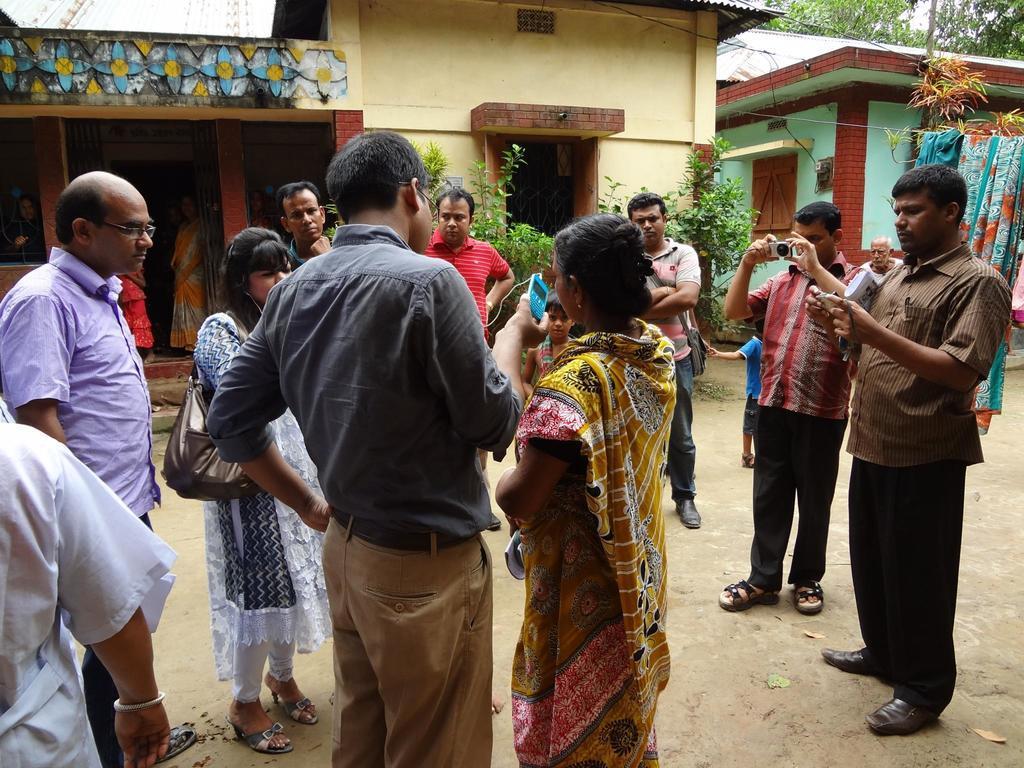In one or two sentences, can you explain what this image depicts? In this image I can see number of people are standing. I can see few of them are holding phones and one is holding a camera. In the background I can see few buildings, plants, trees, clothes and here I can see she is carrying a bag. 